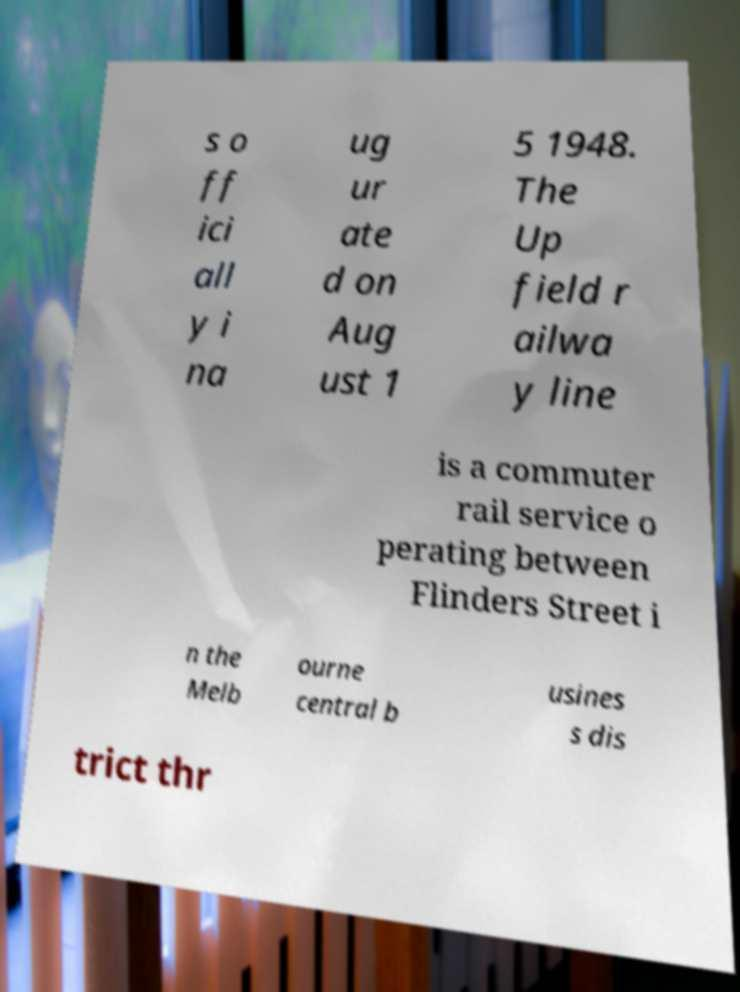Can you accurately transcribe the text from the provided image for me? s o ff ici all y i na ug ur ate d on Aug ust 1 5 1948. The Up field r ailwa y line is a commuter rail service o perating between Flinders Street i n the Melb ourne central b usines s dis trict thr 